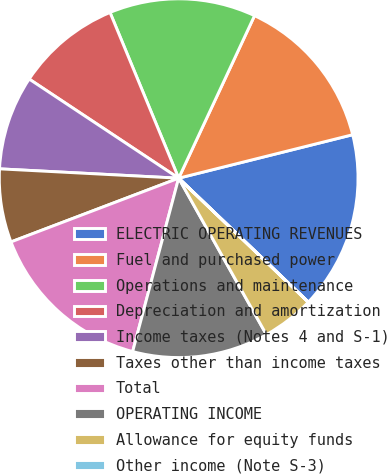Convert chart to OTSL. <chart><loc_0><loc_0><loc_500><loc_500><pie_chart><fcel>ELECTRIC OPERATING REVENUES<fcel>Fuel and purchased power<fcel>Operations and maintenance<fcel>Depreciation and amortization<fcel>Income taxes (Notes 4 and S-1)<fcel>Taxes other than income taxes<fcel>Total<fcel>OPERATING INCOME<fcel>Allowance for equity funds<fcel>Other income (Note S-3)<nl><fcel>16.03%<fcel>14.15%<fcel>13.2%<fcel>9.43%<fcel>8.49%<fcel>6.61%<fcel>15.09%<fcel>12.26%<fcel>4.72%<fcel>0.01%<nl></chart> 